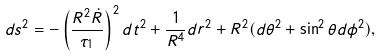<formula> <loc_0><loc_0><loc_500><loc_500>d s ^ { 2 } = - \left ( \frac { R ^ { 2 } { \dot { R } } } { \tau _ { 1 } } \right ) ^ { 2 } d t ^ { 2 } + \frac { 1 } { R ^ { 4 } } d r ^ { 2 } + R ^ { 2 } ( d \theta ^ { 2 } + \sin ^ { 2 } \theta d \phi ^ { 2 } ) ,</formula> 